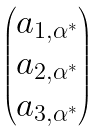Convert formula to latex. <formula><loc_0><loc_0><loc_500><loc_500>\begin{pmatrix} a _ { 1 , \alpha ^ { * } } \\ a _ { 2 , \alpha ^ { * } } \\ a _ { 3 , \alpha ^ { * } } \end{pmatrix}</formula> 